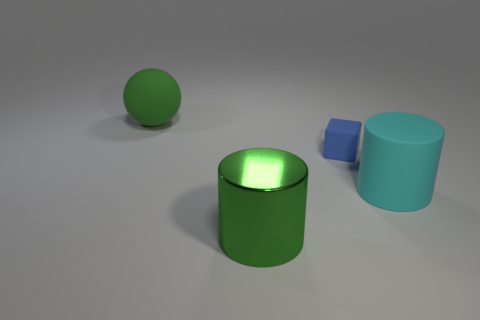Add 3 tiny metallic cylinders. How many objects exist? 7 Subtract all cubes. How many objects are left? 3 Add 1 green metal cylinders. How many green metal cylinders are left? 2 Add 3 large cyan things. How many large cyan things exist? 4 Subtract 0 purple balls. How many objects are left? 4 Subtract all cyan cylinders. Subtract all purple metal spheres. How many objects are left? 3 